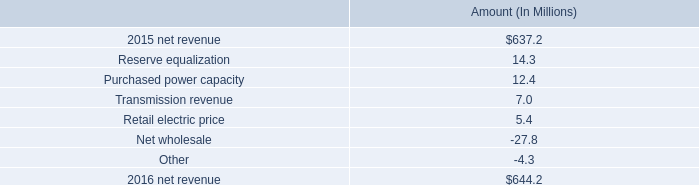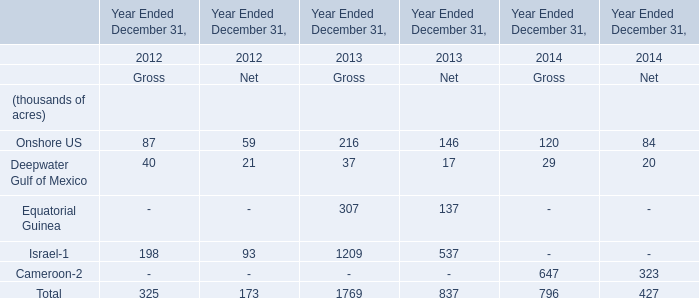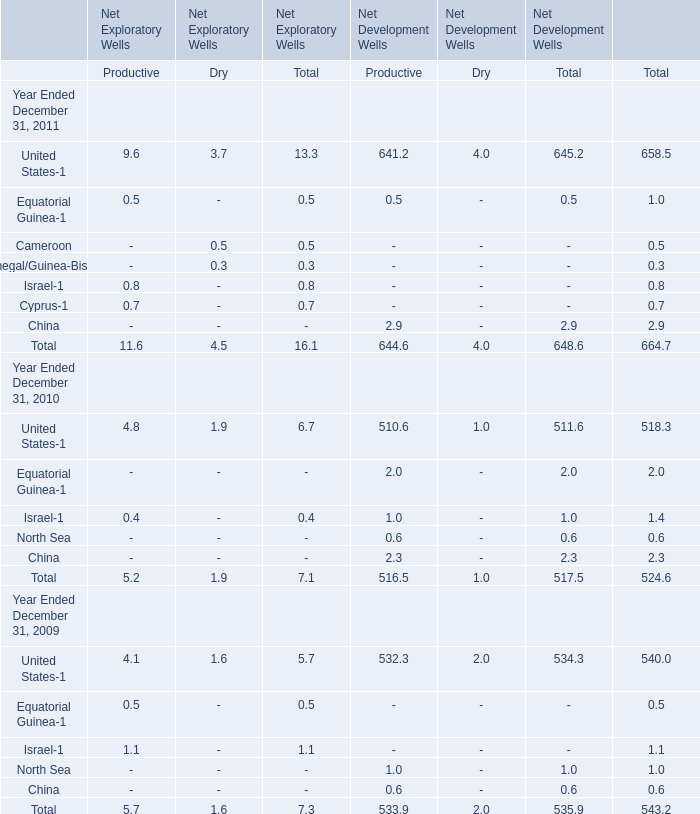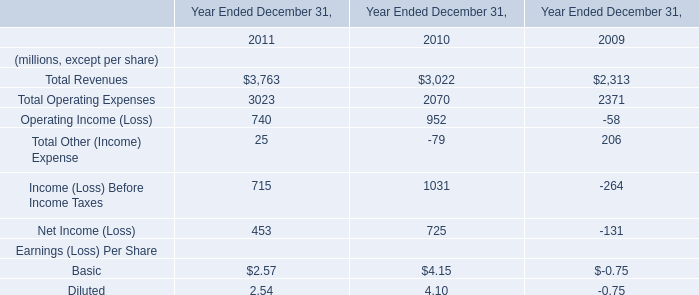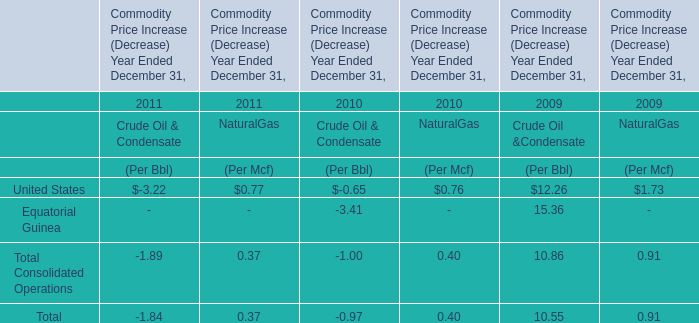What is the sum of United States-1, Equatorial Guinea-1 and Cameroon in 2011 ? 
Computations: ((658.5 + 1) + 0.5)
Answer: 660.0. 